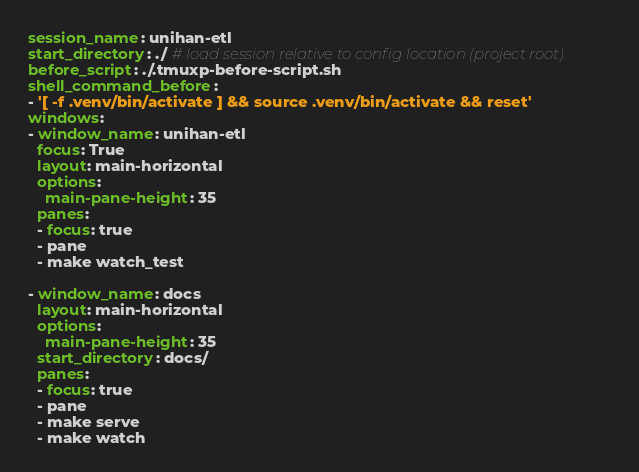<code> <loc_0><loc_0><loc_500><loc_500><_YAML_>session_name: unihan-etl
start_directory: ./ # load session relative to config location (project root).
before_script: ./.tmuxp-before-script.sh
shell_command_before:
- '[ -f .venv/bin/activate ] && source .venv/bin/activate && reset'
windows:
- window_name: unihan-etl
  focus: True
  layout: main-horizontal
  options:
    main-pane-height: 35
  panes:
  - focus: true
  - pane 
  - make watch_test

- window_name: docs
  layout: main-horizontal
  options:
    main-pane-height: 35
  start_directory: docs/
  panes:
  - focus: true
  - pane
  - make serve
  - make watch
</code> 